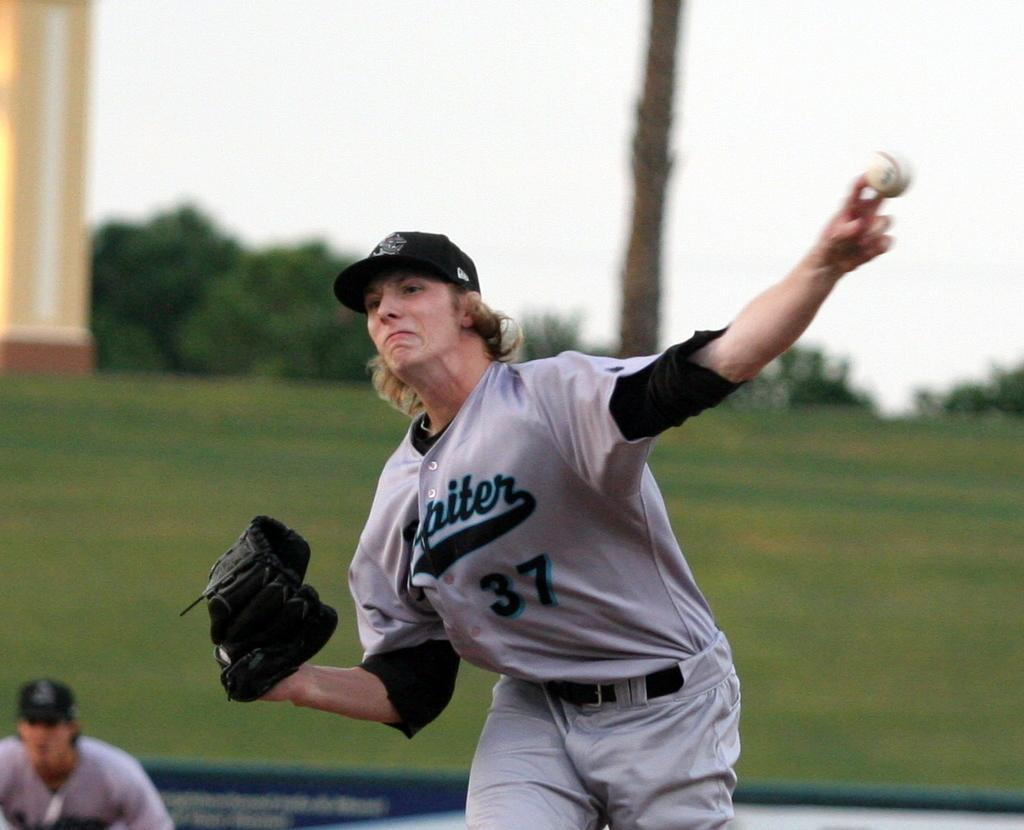<image>
Provide a brief description of the given image. A person in a number 37 jersey is in the middle of throwing a baseball. 